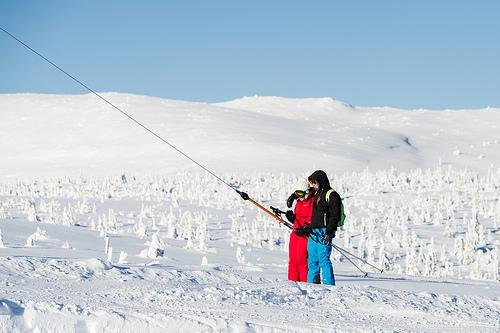Question: how is the weather?
Choices:
A. Very rainy.
B. Very cold.
C. Hot.
D. Humid.
Answer with the letter. Answer: B Question: what are the people doing?
Choices:
A. Golfing.
B. Ice fishing.
C. Driving.
D. Painting.
Answer with the letter. Answer: B Question: where is the person in the blue pants?
Choices:
A. On the chair.
B. On the right.
C. In the front row.
D. With the guest speaker.
Answer with the letter. Answer: B Question: what do they have in their hands?
Choices:
A. Drinks.
B. Fishing poles.
C. Plates.
D. Gloves.
Answer with the letter. Answer: B 